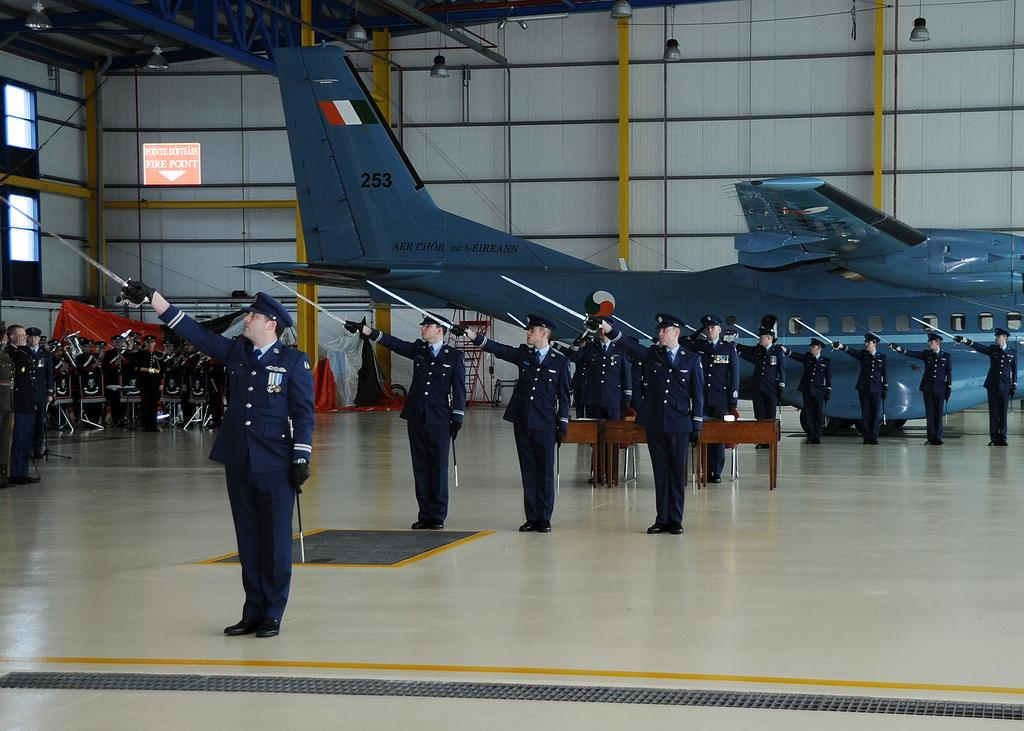<image>
Render a clear and concise summary of the photo. the words fire point are on the sign 